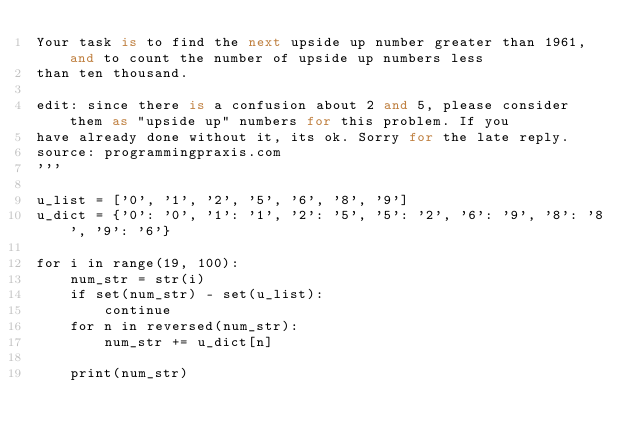Convert code to text. <code><loc_0><loc_0><loc_500><loc_500><_Python_>Your task is to find the next upside up number greater than 1961, and to count the number of upside up numbers less
than ten thousand.

edit: since there is a confusion about 2 and 5, please consider them as "upside up" numbers for this problem. If you
have already done without it, its ok. Sorry for the late reply.
source: programmingpraxis.com
'''

u_list = ['0', '1', '2', '5', '6', '8', '9']
u_dict = {'0': '0', '1': '1', '2': '5', '5': '2', '6': '9', '8': '8', '9': '6'}

for i in range(19, 100):
    num_str = str(i)
    if set(num_str) - set(u_list):
        continue
    for n in reversed(num_str):
        num_str += u_dict[n]

    print(num_str)</code> 